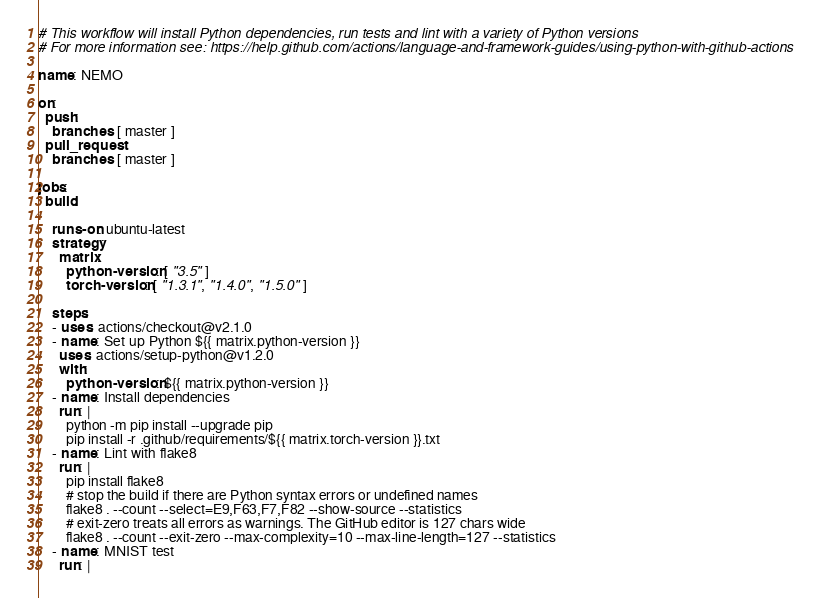<code> <loc_0><loc_0><loc_500><loc_500><_YAML_># This workflow will install Python dependencies, run tests and lint with a variety of Python versions
# For more information see: https://help.github.com/actions/language-and-framework-guides/using-python-with-github-actions

name: NEMO

on:
  push:
    branches: [ master ]
  pull_request:
    branches: [ master ]

jobs:
  build:

    runs-on: ubuntu-latest
    strategy:
      matrix:
        python-version: [ "3.5" ]
        torch-version: [ "1.3.1", "1.4.0", "1.5.0" ]

    steps:
    - uses: actions/checkout@v2.1.0
    - name: Set up Python ${{ matrix.python-version }}
      uses: actions/setup-python@v1.2.0
      with:
        python-version: ${{ matrix.python-version }}
    - name: Install dependencies
      run: |
        python -m pip install --upgrade pip
        pip install -r .github/requirements/${{ matrix.torch-version }}.txt
    - name: Lint with flake8
      run: |
        pip install flake8
        # stop the build if there are Python syntax errors or undefined names
        flake8 . --count --select=E9,F63,F7,F82 --show-source --statistics
        # exit-zero treats all errors as warnings. The GitHub editor is 127 chars wide
        flake8 . --count --exit-zero --max-complexity=10 --max-line-length=127 --statistics
    - name: MNIST test
      run: |</code> 